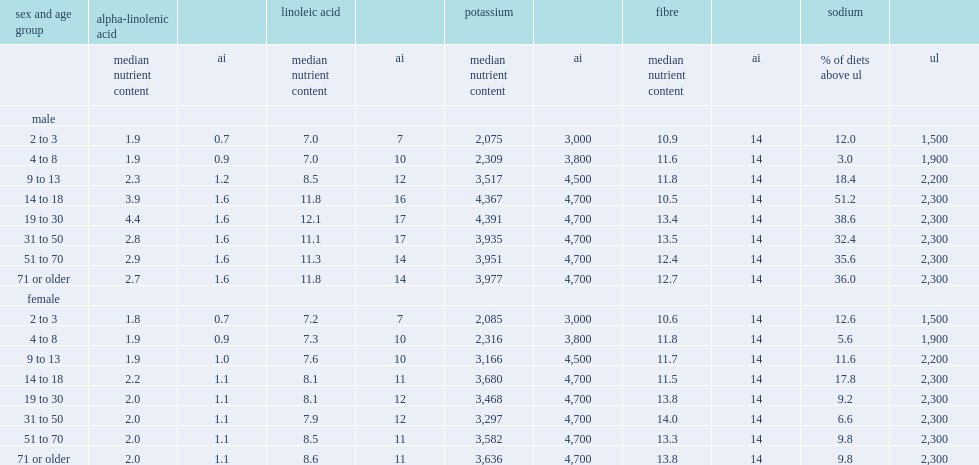What was the smallest percentage of the simulated diets with sodium content above the ul? 3. What was the largest percentage of the simulated diets with sodium content above the ul? 51.2. 